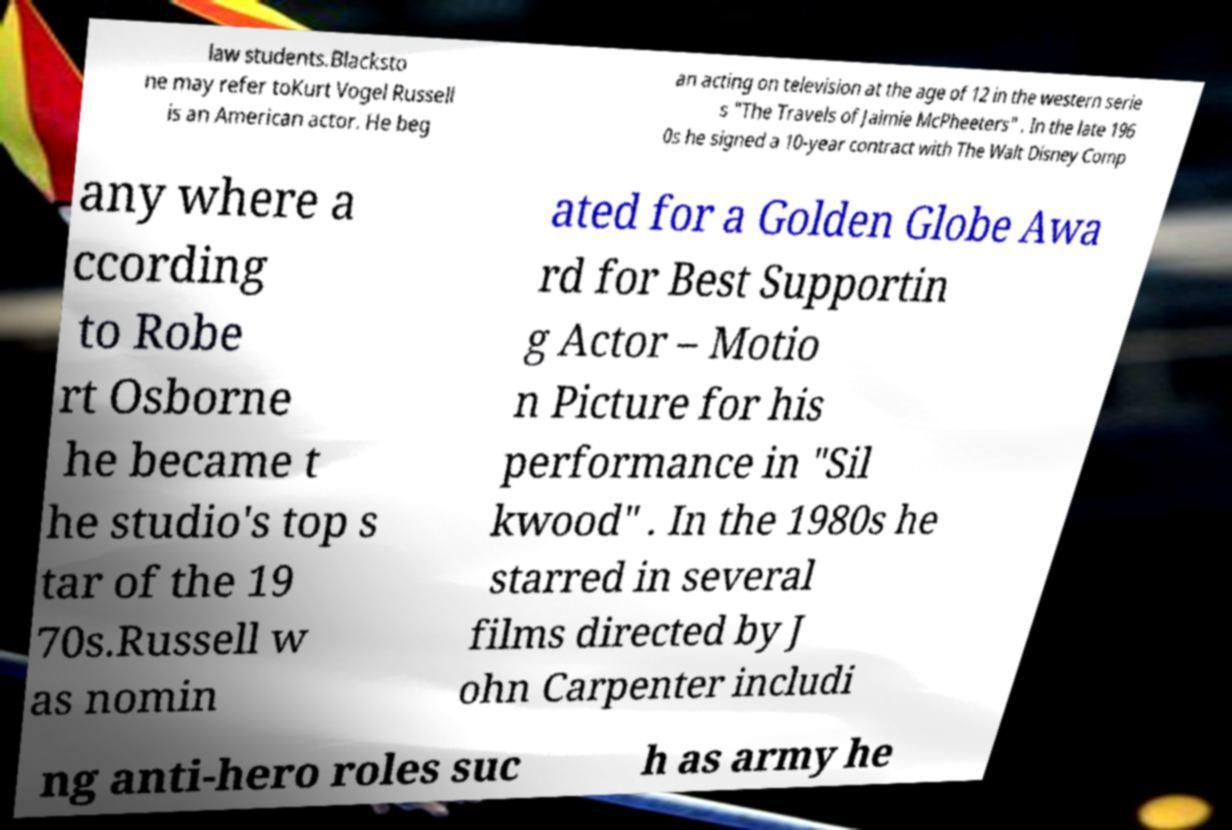Could you extract and type out the text from this image? law students.Blacksto ne may refer toKurt Vogel Russell is an American actor. He beg an acting on television at the age of 12 in the western serie s "The Travels of Jaimie McPheeters" . In the late 196 0s he signed a 10-year contract with The Walt Disney Comp any where a ccording to Robe rt Osborne he became t he studio's top s tar of the 19 70s.Russell w as nomin ated for a Golden Globe Awa rd for Best Supportin g Actor – Motio n Picture for his performance in "Sil kwood" . In the 1980s he starred in several films directed by J ohn Carpenter includi ng anti-hero roles suc h as army he 